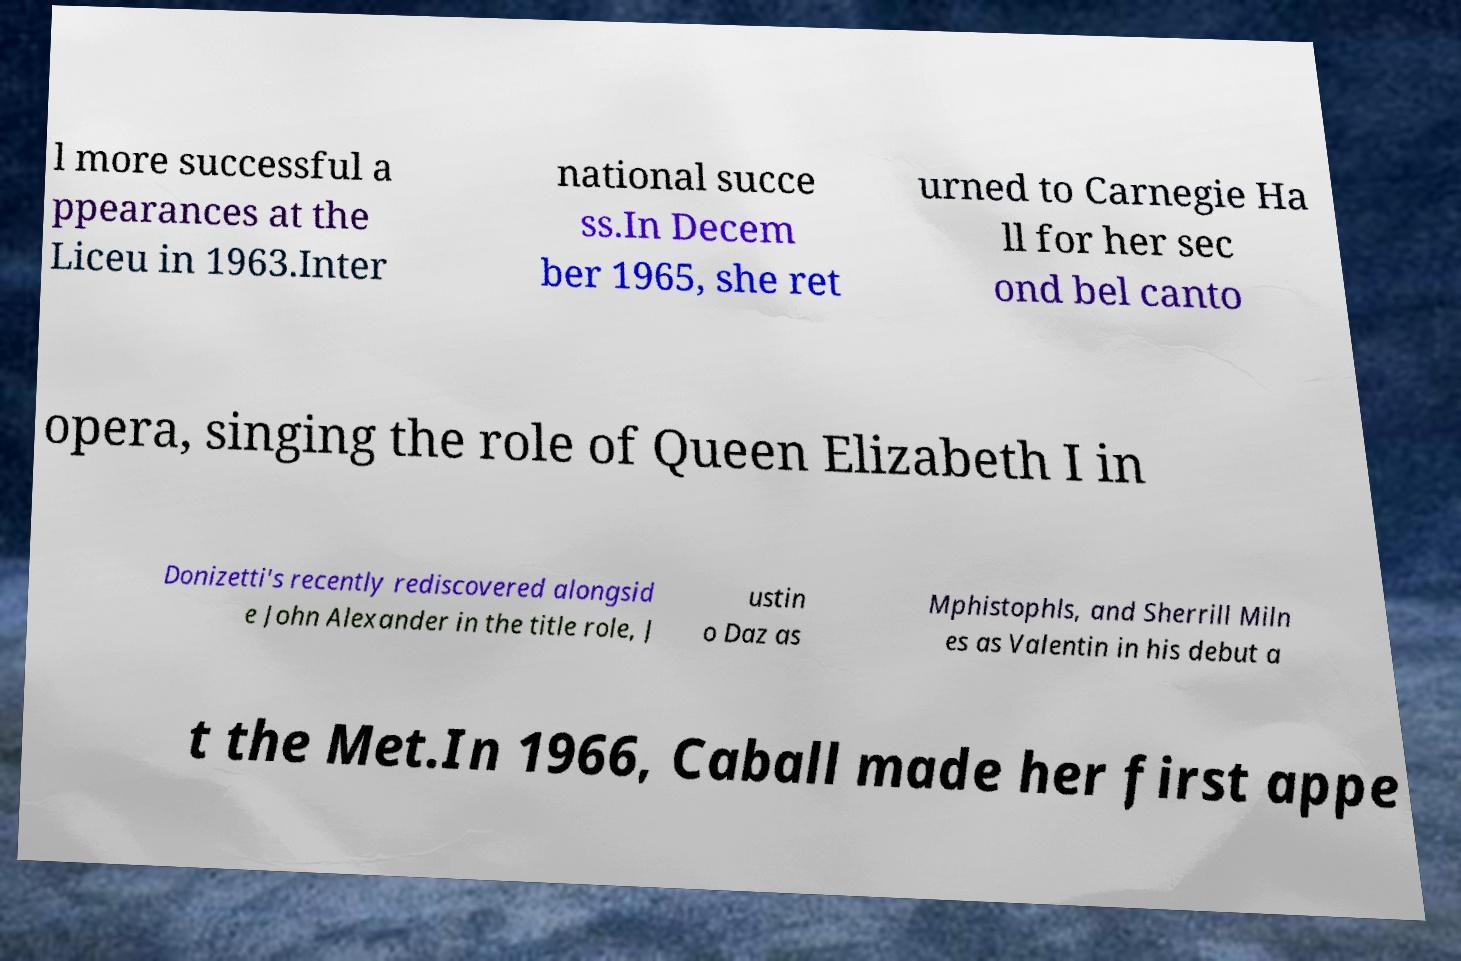Could you assist in decoding the text presented in this image and type it out clearly? l more successful a ppearances at the Liceu in 1963.Inter national succe ss.In Decem ber 1965, she ret urned to Carnegie Ha ll for her sec ond bel canto opera, singing the role of Queen Elizabeth I in Donizetti's recently rediscovered alongsid e John Alexander in the title role, J ustin o Daz as Mphistophls, and Sherrill Miln es as Valentin in his debut a t the Met.In 1966, Caball made her first appe 